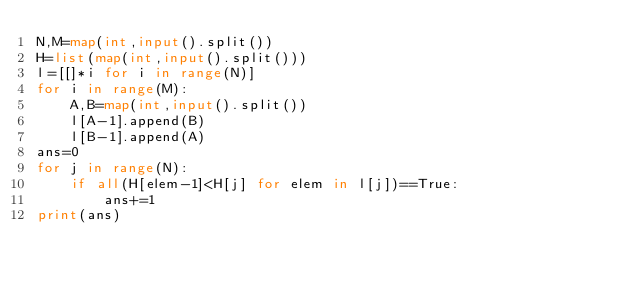<code> <loc_0><loc_0><loc_500><loc_500><_Python_>N,M=map(int,input().split())
H=list(map(int,input().split()))
l=[[]*i for i in range(N)]
for i in range(M):
    A,B=map(int,input().split())
    l[A-1].append(B)
    l[B-1].append(A)
ans=0
for j in range(N):
    if all(H[elem-1]<H[j] for elem in l[j])==True:
        ans+=1
print(ans)







    


    












</code> 